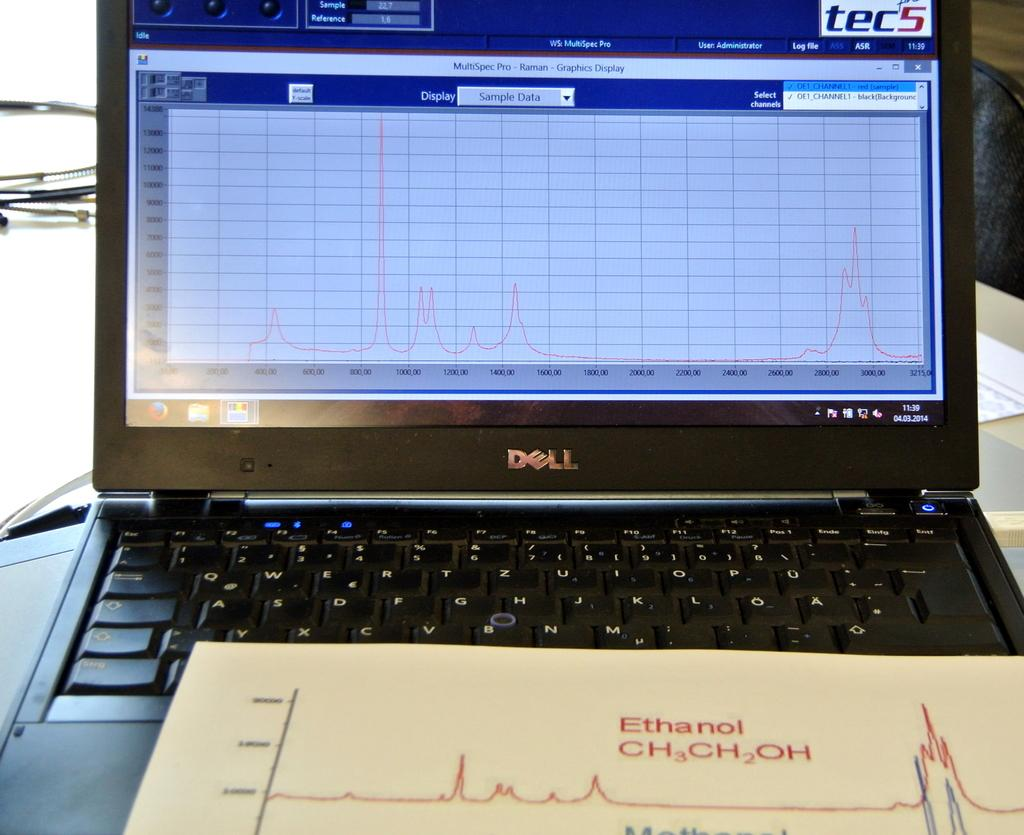<image>
Write a terse but informative summary of the picture. A person is studying the formula Ethanol ch3ch2oh 